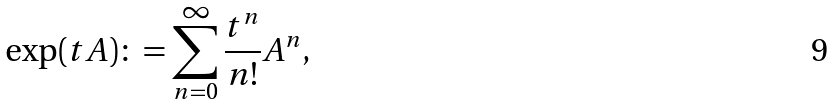<formula> <loc_0><loc_0><loc_500><loc_500>\exp ( t A ) \colon = \sum _ { n = 0 } ^ { \infty } \frac { t ^ { n } } { n ! } A ^ { n } ,</formula> 